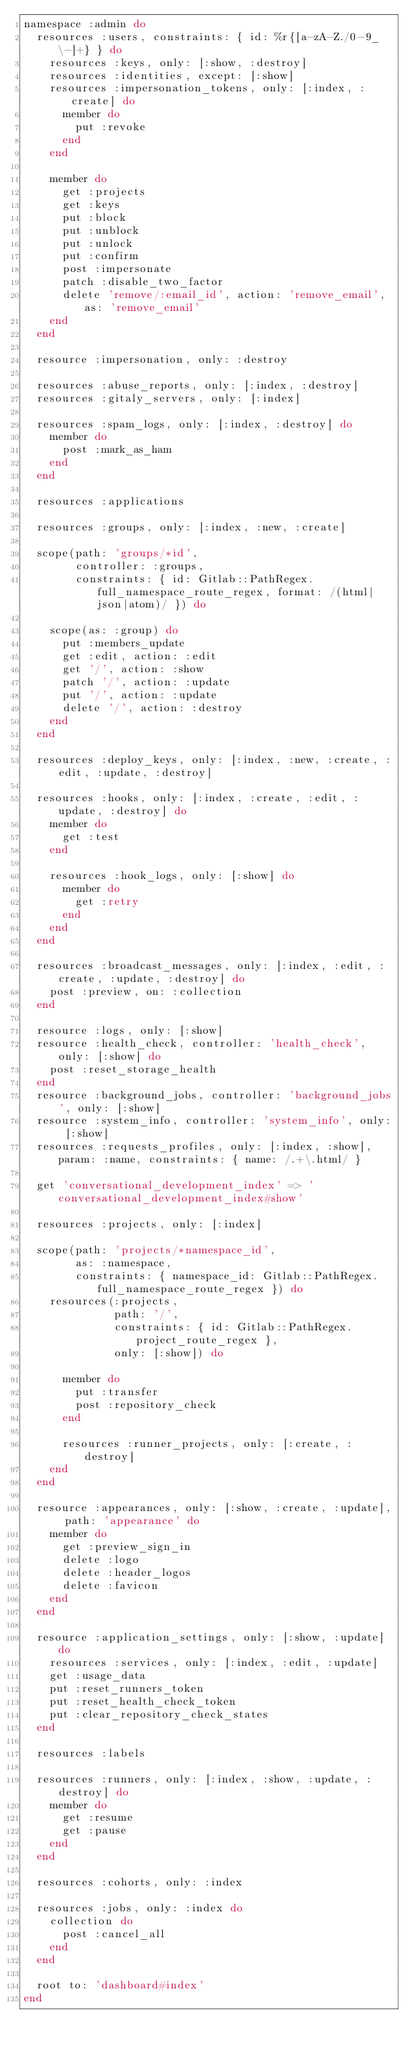Convert code to text. <code><loc_0><loc_0><loc_500><loc_500><_Ruby_>namespace :admin do
  resources :users, constraints: { id: %r{[a-zA-Z./0-9_\-]+} } do
    resources :keys, only: [:show, :destroy]
    resources :identities, except: [:show]
    resources :impersonation_tokens, only: [:index, :create] do
      member do
        put :revoke
      end
    end

    member do
      get :projects
      get :keys
      put :block
      put :unblock
      put :unlock
      put :confirm
      post :impersonate
      patch :disable_two_factor
      delete 'remove/:email_id', action: 'remove_email', as: 'remove_email'
    end
  end

  resource :impersonation, only: :destroy

  resources :abuse_reports, only: [:index, :destroy]
  resources :gitaly_servers, only: [:index]

  resources :spam_logs, only: [:index, :destroy] do
    member do
      post :mark_as_ham
    end
  end

  resources :applications

  resources :groups, only: [:index, :new, :create]

  scope(path: 'groups/*id',
        controller: :groups,
        constraints: { id: Gitlab::PathRegex.full_namespace_route_regex, format: /(html|json|atom)/ }) do

    scope(as: :group) do
      put :members_update
      get :edit, action: :edit
      get '/', action: :show
      patch '/', action: :update
      put '/', action: :update
      delete '/', action: :destroy
    end
  end

  resources :deploy_keys, only: [:index, :new, :create, :edit, :update, :destroy]

  resources :hooks, only: [:index, :create, :edit, :update, :destroy] do
    member do
      get :test
    end

    resources :hook_logs, only: [:show] do
      member do
        get :retry
      end
    end
  end

  resources :broadcast_messages, only: [:index, :edit, :create, :update, :destroy] do
    post :preview, on: :collection
  end

  resource :logs, only: [:show]
  resource :health_check, controller: 'health_check', only: [:show] do
    post :reset_storage_health
  end
  resource :background_jobs, controller: 'background_jobs', only: [:show]
  resource :system_info, controller: 'system_info', only: [:show]
  resources :requests_profiles, only: [:index, :show], param: :name, constraints: { name: /.+\.html/ }

  get 'conversational_development_index' => 'conversational_development_index#show'

  resources :projects, only: [:index]

  scope(path: 'projects/*namespace_id',
        as: :namespace,
        constraints: { namespace_id: Gitlab::PathRegex.full_namespace_route_regex }) do
    resources(:projects,
              path: '/',
              constraints: { id: Gitlab::PathRegex.project_route_regex },
              only: [:show]) do

      member do
        put :transfer
        post :repository_check
      end

      resources :runner_projects, only: [:create, :destroy]
    end
  end

  resource :appearances, only: [:show, :create, :update], path: 'appearance' do
    member do
      get :preview_sign_in
      delete :logo
      delete :header_logos
      delete :favicon
    end
  end

  resource :application_settings, only: [:show, :update] do
    resources :services, only: [:index, :edit, :update]
    get :usage_data
    put :reset_runners_token
    put :reset_health_check_token
    put :clear_repository_check_states
  end

  resources :labels

  resources :runners, only: [:index, :show, :update, :destroy] do
    member do
      get :resume
      get :pause
    end
  end

  resources :cohorts, only: :index

  resources :jobs, only: :index do
    collection do
      post :cancel_all
    end
  end

  root to: 'dashboard#index'
end
</code> 